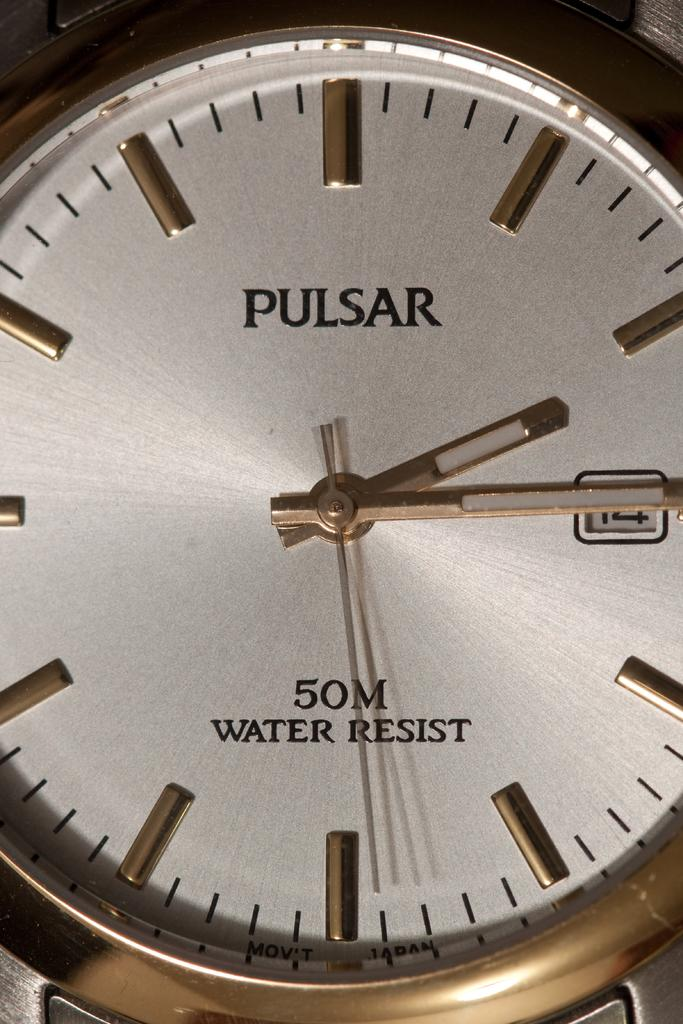<image>
Create a compact narrative representing the image presented. The closeup of this pulsar watch shows that it is water resistant. 